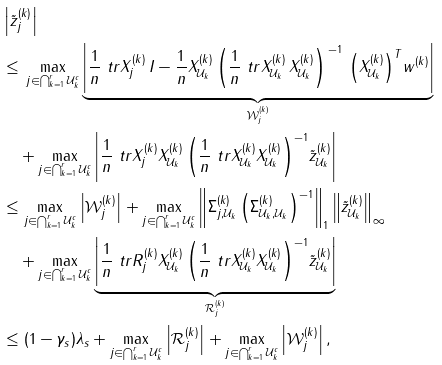<formula> <loc_0><loc_0><loc_500><loc_500>& \left | \tilde { z } ^ { ( k ) } _ { j } \right | \\ & \leq \, \max _ { j \in \bigcap _ { k = 1 } ^ { r } \mathcal { U } _ { k } ^ { c } } \underbrace { \left | \frac { 1 } { n } \ t r { X ^ { ( k ) } _ { j } \, } { I - \frac { 1 } { n } X ^ { ( k ) } _ { \mathcal { U } _ { k } } \left ( \frac { 1 } { n } \ t r { X ^ { ( k ) } _ { \mathcal { U } _ { k } } \, } { X ^ { ( k ) } _ { \mathcal { U } _ { k } } } \right ) ^ { \, - 1 } \, \left ( X ^ { ( k ) } _ { \mathcal { U } _ { k } } \right ) ^ { T } } w ^ { ( k ) } \right | } _ { \mathcal { W } _ { j } ^ { ( k ) } } \\ & \quad + \max _ { j \in \bigcap _ { k = 1 } ^ { r } \mathcal { U } _ { k } ^ { c } } \left | \frac { 1 } { n } \ t r { X ^ { ( k ) } _ { j } } { X ^ { ( k ) } _ { \mathcal { U } _ { k } } \left ( \frac { 1 } { n } \ t r { X ^ { ( k ) } _ { \mathcal { U } _ { k } } } { X ^ { ( k ) } _ { \mathcal { U } _ { k } } } \right ) ^ { - 1 } } \tilde { z } ^ { ( k ) } _ { \mathcal { U } _ { k } } \right | \\ & \leq \max _ { j \in \bigcap _ { k = 1 } ^ { r } \mathcal { U } _ { k } ^ { c } } \left | \mathcal { W } _ { j } ^ { ( k ) } \right | + \max _ { j \in \bigcap _ { k = 1 } ^ { r } \mathcal { U } _ { k } ^ { c } } \left \| \Sigma ^ { ( k ) } _ { j , \mathcal { U } _ { k } } \left ( \Sigma ^ { ( k ) } _ { \mathcal { U } _ { k } , \mathcal { U } _ { k } } \right ) ^ { - 1 } \right \| _ { 1 } \left \| \tilde { z } ^ { ( k ) } _ { \mathcal { U } _ { k } } \right \| _ { \infty } \\ & \quad + \max _ { j \in \bigcap _ { k = 1 } ^ { r } \mathcal { U } _ { k } ^ { c } } \underbrace { \left | \frac { 1 } { n } \ t r { R ^ { ( k ) } _ { j } } { X ^ { ( k ) } _ { \mathcal { U } _ { k } } \left ( \frac { 1 } { n } \ t r { X ^ { ( k ) } _ { \mathcal { U } _ { k } } } { X ^ { ( k ) } _ { \mathcal { U } _ { k } } } \right ) ^ { - 1 } } \tilde { z } ^ { ( k ) } _ { \mathcal { U } _ { k } } \right | } _ { \mathcal { R } _ { j } ^ { ( k ) } } \\ & \leq ( 1 - \gamma _ { s } ) \lambda _ { s } + \max _ { j \in \bigcap _ { k = 1 } ^ { r } \mathcal { U } _ { k } ^ { c } } \left | \mathcal { R } _ { j } ^ { ( k ) } \right | + \max _ { j \in \bigcap _ { k = 1 } ^ { r } \mathcal { U } _ { k } ^ { c } } \left | \mathcal { W } _ { j } ^ { ( k ) } \right | ,</formula> 